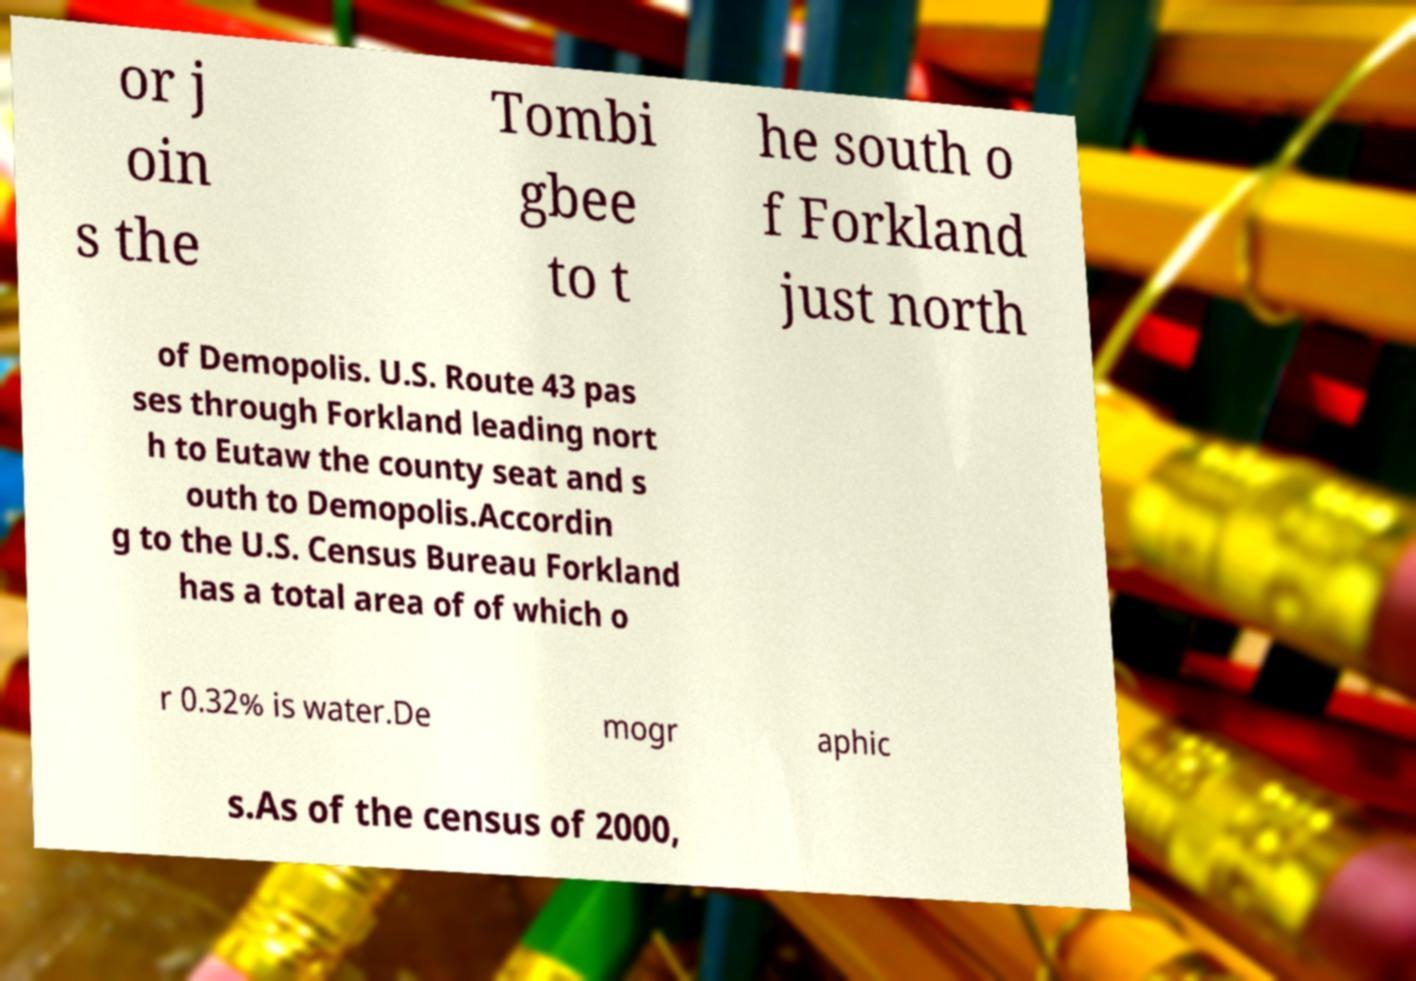Please identify and transcribe the text found in this image. or j oin s the Tombi gbee to t he south o f Forkland just north of Demopolis. U.S. Route 43 pas ses through Forkland leading nort h to Eutaw the county seat and s outh to Demopolis.Accordin g to the U.S. Census Bureau Forkland has a total area of of which o r 0.32% is water.De mogr aphic s.As of the census of 2000, 